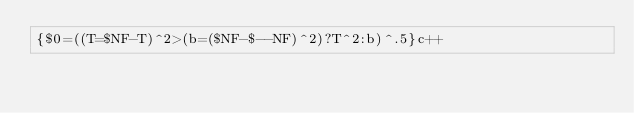<code> <loc_0><loc_0><loc_500><loc_500><_Awk_>{$0=((T=$NF-T)^2>(b=($NF-$--NF)^2)?T^2:b)^.5}c++</code> 